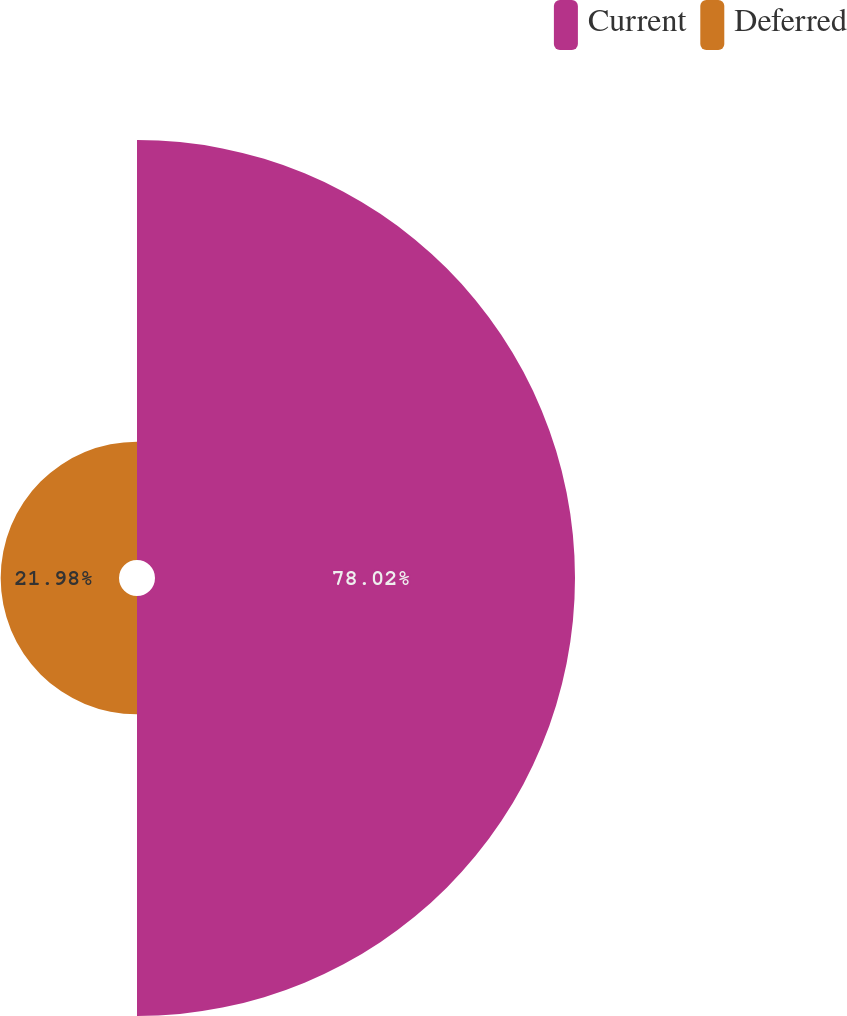<chart> <loc_0><loc_0><loc_500><loc_500><pie_chart><fcel>Current<fcel>Deferred<nl><fcel>78.02%<fcel>21.98%<nl></chart> 